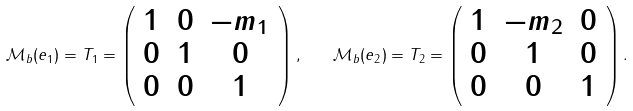Convert formula to latex. <formula><loc_0><loc_0><loc_500><loc_500>\mathcal { M } _ { b } ( e _ { 1 } ) = T _ { 1 } = \left ( \begin{array} { c c c } 1 & 0 & - m _ { 1 } \\ 0 & 1 & 0 \\ 0 & 0 & 1 \end{array} \right ) , \quad \mathcal { M } _ { b } ( e _ { 2 } ) = T _ { 2 } = \left ( \begin{array} { c c c } 1 & - m _ { 2 } & 0 \\ 0 & 1 & 0 \\ 0 & 0 & 1 \end{array} \right ) .</formula> 